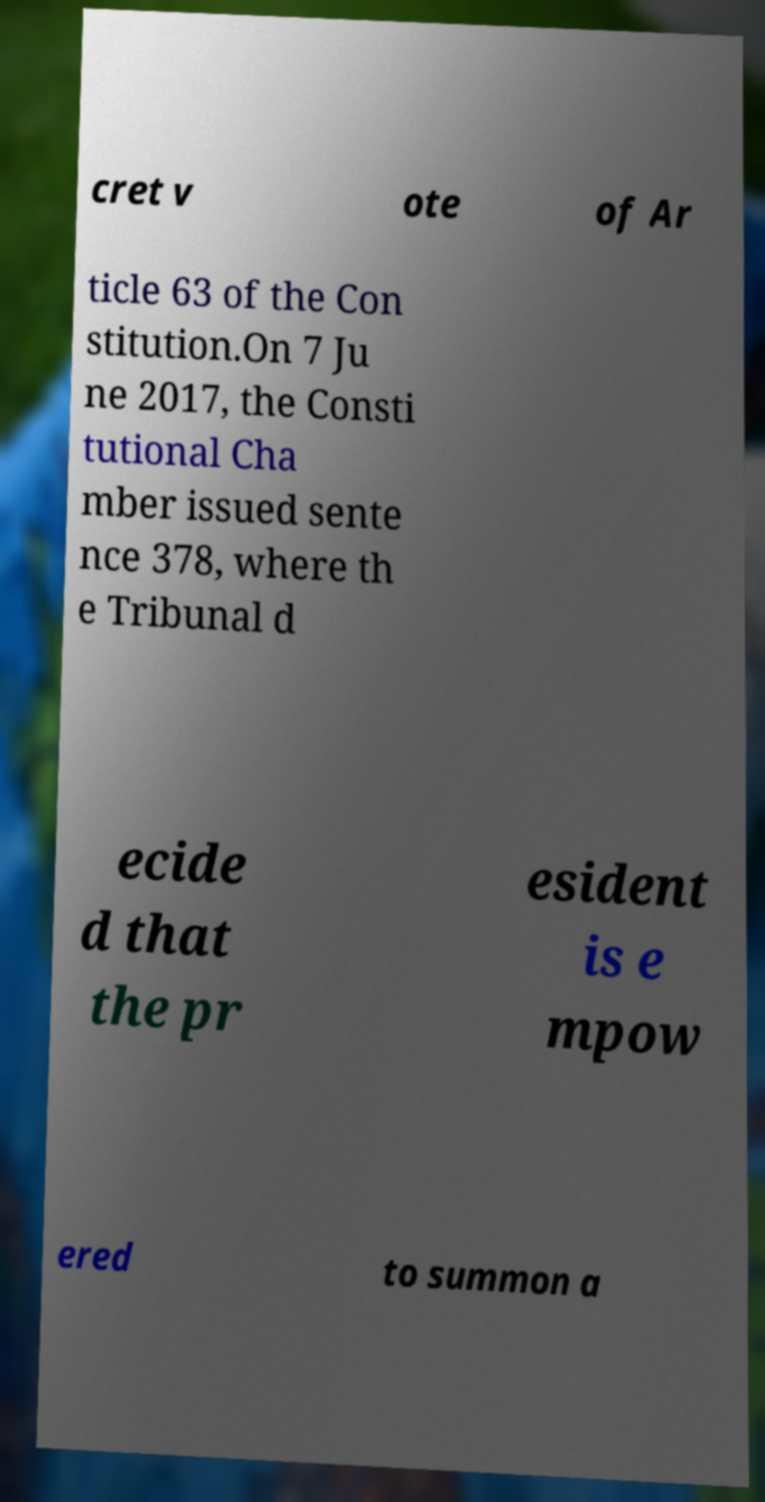Please read and relay the text visible in this image. What does it say? cret v ote of Ar ticle 63 of the Con stitution.On 7 Ju ne 2017, the Consti tutional Cha mber issued sente nce 378, where th e Tribunal d ecide d that the pr esident is e mpow ered to summon a 